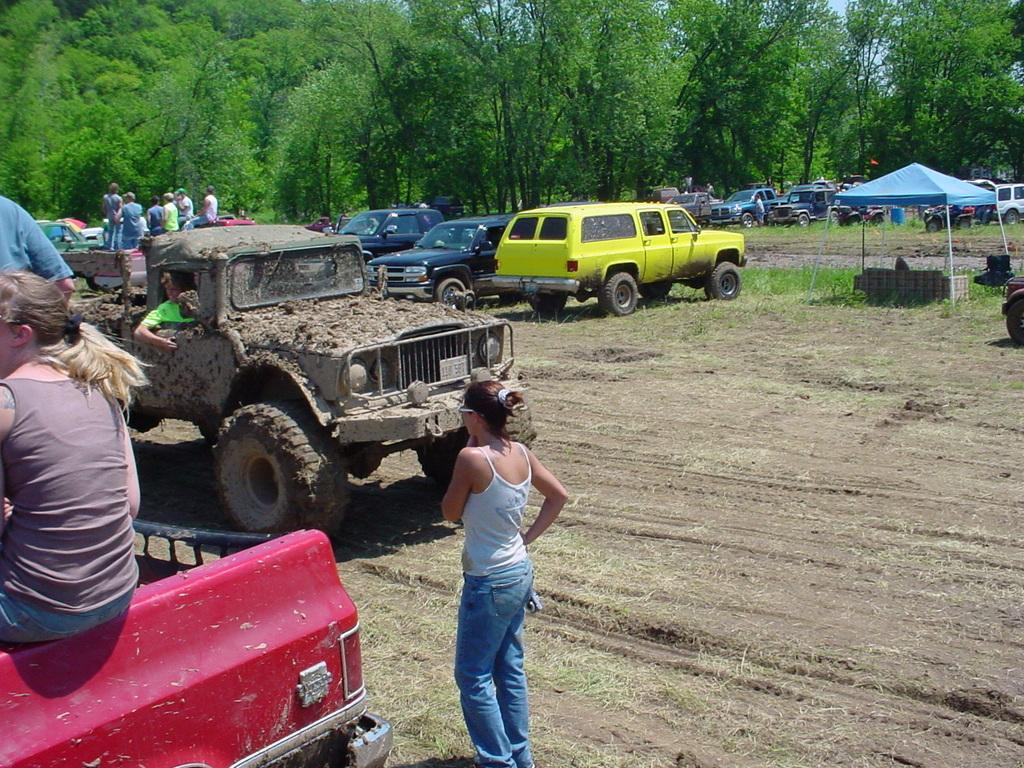Who or what can be seen in the image? There are people and vehicles in the image. What is the ground like in the image? The ground is visible in the image, and it appears to have grass. What can be seen in the background of the image? There are trees and the sky visible in the background of the image. What scientific experiments are being conducted in the cave shown in the image? There is no cave present in the image, and therefore no scientific experiments can be observed. 